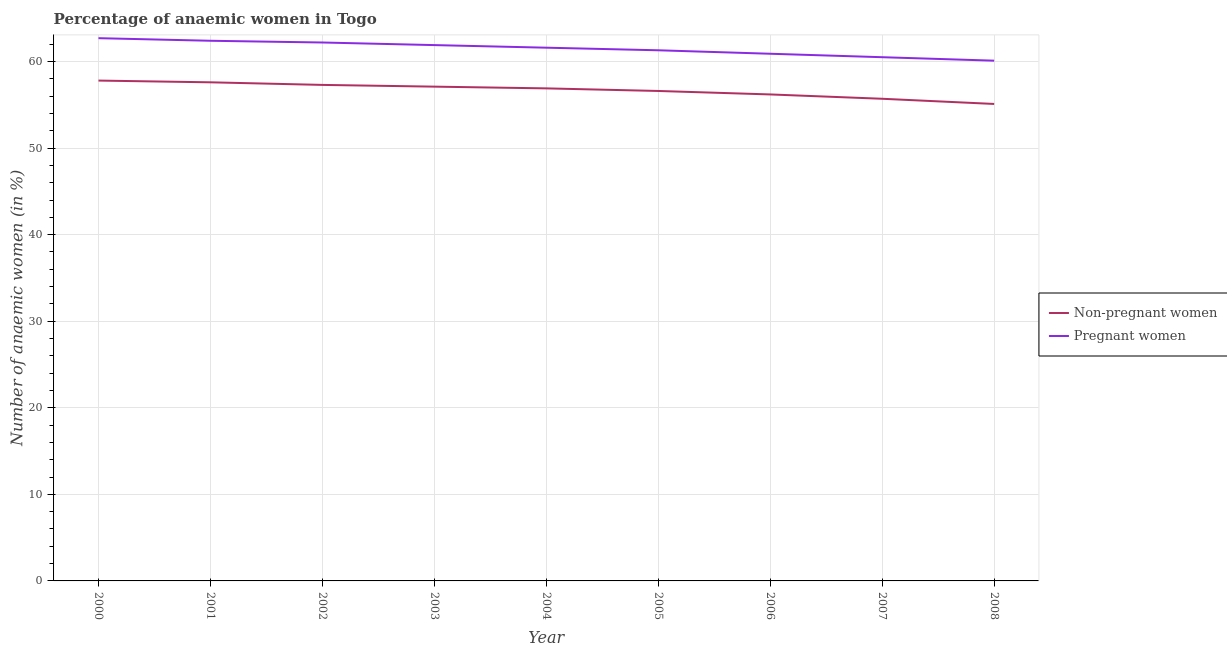Is the number of lines equal to the number of legend labels?
Your answer should be very brief. Yes. What is the percentage of pregnant anaemic women in 2006?
Offer a very short reply. 60.9. Across all years, what is the maximum percentage of non-pregnant anaemic women?
Your answer should be very brief. 57.8. Across all years, what is the minimum percentage of pregnant anaemic women?
Ensure brevity in your answer.  60.1. In which year was the percentage of non-pregnant anaemic women minimum?
Your answer should be very brief. 2008. What is the total percentage of non-pregnant anaemic women in the graph?
Keep it short and to the point. 510.3. What is the difference between the percentage of non-pregnant anaemic women in 2000 and that in 2004?
Give a very brief answer. 0.9. What is the average percentage of non-pregnant anaemic women per year?
Keep it short and to the point. 56.7. In the year 2002, what is the difference between the percentage of non-pregnant anaemic women and percentage of pregnant anaemic women?
Provide a short and direct response. -4.9. In how many years, is the percentage of non-pregnant anaemic women greater than 34 %?
Give a very brief answer. 9. What is the ratio of the percentage of pregnant anaemic women in 2003 to that in 2007?
Offer a very short reply. 1.02. Is the percentage of pregnant anaemic women in 2004 less than that in 2007?
Ensure brevity in your answer.  No. Is the difference between the percentage of pregnant anaemic women in 2002 and 2004 greater than the difference between the percentage of non-pregnant anaemic women in 2002 and 2004?
Your response must be concise. Yes. What is the difference between the highest and the second highest percentage of pregnant anaemic women?
Give a very brief answer. 0.3. What is the difference between the highest and the lowest percentage of non-pregnant anaemic women?
Provide a short and direct response. 2.7. Is the sum of the percentage of non-pregnant anaemic women in 2004 and 2008 greater than the maximum percentage of pregnant anaemic women across all years?
Your answer should be compact. Yes. Does the percentage of pregnant anaemic women monotonically increase over the years?
Provide a short and direct response. No. Are the values on the major ticks of Y-axis written in scientific E-notation?
Provide a short and direct response. No. Does the graph contain grids?
Provide a succinct answer. Yes. How are the legend labels stacked?
Provide a succinct answer. Vertical. What is the title of the graph?
Provide a succinct answer. Percentage of anaemic women in Togo. Does "State government" appear as one of the legend labels in the graph?
Ensure brevity in your answer.  No. What is the label or title of the Y-axis?
Provide a short and direct response. Number of anaemic women (in %). What is the Number of anaemic women (in %) of Non-pregnant women in 2000?
Offer a very short reply. 57.8. What is the Number of anaemic women (in %) in Pregnant women in 2000?
Provide a succinct answer. 62.7. What is the Number of anaemic women (in %) in Non-pregnant women in 2001?
Make the answer very short. 57.6. What is the Number of anaemic women (in %) in Pregnant women in 2001?
Your answer should be very brief. 62.4. What is the Number of anaemic women (in %) in Non-pregnant women in 2002?
Keep it short and to the point. 57.3. What is the Number of anaemic women (in %) in Pregnant women in 2002?
Your answer should be very brief. 62.2. What is the Number of anaemic women (in %) in Non-pregnant women in 2003?
Your answer should be compact. 57.1. What is the Number of anaemic women (in %) in Pregnant women in 2003?
Give a very brief answer. 61.9. What is the Number of anaemic women (in %) in Non-pregnant women in 2004?
Provide a short and direct response. 56.9. What is the Number of anaemic women (in %) in Pregnant women in 2004?
Provide a short and direct response. 61.6. What is the Number of anaemic women (in %) in Non-pregnant women in 2005?
Your answer should be very brief. 56.6. What is the Number of anaemic women (in %) of Pregnant women in 2005?
Make the answer very short. 61.3. What is the Number of anaemic women (in %) in Non-pregnant women in 2006?
Provide a succinct answer. 56.2. What is the Number of anaemic women (in %) in Pregnant women in 2006?
Ensure brevity in your answer.  60.9. What is the Number of anaemic women (in %) of Non-pregnant women in 2007?
Provide a succinct answer. 55.7. What is the Number of anaemic women (in %) in Pregnant women in 2007?
Keep it short and to the point. 60.5. What is the Number of anaemic women (in %) of Non-pregnant women in 2008?
Make the answer very short. 55.1. What is the Number of anaemic women (in %) in Pregnant women in 2008?
Your response must be concise. 60.1. Across all years, what is the maximum Number of anaemic women (in %) of Non-pregnant women?
Offer a very short reply. 57.8. Across all years, what is the maximum Number of anaemic women (in %) in Pregnant women?
Your answer should be compact. 62.7. Across all years, what is the minimum Number of anaemic women (in %) in Non-pregnant women?
Offer a terse response. 55.1. Across all years, what is the minimum Number of anaemic women (in %) in Pregnant women?
Give a very brief answer. 60.1. What is the total Number of anaemic women (in %) in Non-pregnant women in the graph?
Your response must be concise. 510.3. What is the total Number of anaemic women (in %) of Pregnant women in the graph?
Your response must be concise. 553.6. What is the difference between the Number of anaemic women (in %) of Pregnant women in 2000 and that in 2001?
Offer a very short reply. 0.3. What is the difference between the Number of anaemic women (in %) of Non-pregnant women in 2000 and that in 2002?
Offer a very short reply. 0.5. What is the difference between the Number of anaemic women (in %) in Pregnant women in 2000 and that in 2002?
Make the answer very short. 0.5. What is the difference between the Number of anaemic women (in %) in Non-pregnant women in 2000 and that in 2004?
Keep it short and to the point. 0.9. What is the difference between the Number of anaemic women (in %) of Pregnant women in 2000 and that in 2005?
Your answer should be very brief. 1.4. What is the difference between the Number of anaemic women (in %) in Non-pregnant women in 2000 and that in 2006?
Keep it short and to the point. 1.6. What is the difference between the Number of anaemic women (in %) of Pregnant women in 2000 and that in 2006?
Provide a short and direct response. 1.8. What is the difference between the Number of anaemic women (in %) in Non-pregnant women in 2000 and that in 2007?
Your answer should be very brief. 2.1. What is the difference between the Number of anaemic women (in %) of Pregnant women in 2000 and that in 2007?
Your answer should be compact. 2.2. What is the difference between the Number of anaemic women (in %) in Pregnant women in 2000 and that in 2008?
Your response must be concise. 2.6. What is the difference between the Number of anaemic women (in %) in Non-pregnant women in 2001 and that in 2002?
Offer a terse response. 0.3. What is the difference between the Number of anaemic women (in %) in Pregnant women in 2001 and that in 2002?
Your answer should be compact. 0.2. What is the difference between the Number of anaemic women (in %) of Pregnant women in 2001 and that in 2003?
Your answer should be very brief. 0.5. What is the difference between the Number of anaemic women (in %) of Pregnant women in 2001 and that in 2006?
Offer a very short reply. 1.5. What is the difference between the Number of anaemic women (in %) in Non-pregnant women in 2002 and that in 2003?
Give a very brief answer. 0.2. What is the difference between the Number of anaemic women (in %) of Non-pregnant women in 2002 and that in 2004?
Your answer should be compact. 0.4. What is the difference between the Number of anaemic women (in %) of Pregnant women in 2002 and that in 2004?
Your answer should be compact. 0.6. What is the difference between the Number of anaemic women (in %) of Non-pregnant women in 2002 and that in 2005?
Make the answer very short. 0.7. What is the difference between the Number of anaemic women (in %) of Non-pregnant women in 2002 and that in 2006?
Provide a short and direct response. 1.1. What is the difference between the Number of anaemic women (in %) of Pregnant women in 2002 and that in 2006?
Offer a very short reply. 1.3. What is the difference between the Number of anaemic women (in %) of Pregnant women in 2002 and that in 2007?
Give a very brief answer. 1.7. What is the difference between the Number of anaemic women (in %) of Non-pregnant women in 2003 and that in 2005?
Your answer should be very brief. 0.5. What is the difference between the Number of anaemic women (in %) of Non-pregnant women in 2003 and that in 2006?
Make the answer very short. 0.9. What is the difference between the Number of anaemic women (in %) of Non-pregnant women in 2003 and that in 2007?
Your answer should be very brief. 1.4. What is the difference between the Number of anaemic women (in %) in Pregnant women in 2003 and that in 2007?
Your response must be concise. 1.4. What is the difference between the Number of anaemic women (in %) of Non-pregnant women in 2003 and that in 2008?
Ensure brevity in your answer.  2. What is the difference between the Number of anaemic women (in %) in Pregnant women in 2003 and that in 2008?
Keep it short and to the point. 1.8. What is the difference between the Number of anaemic women (in %) in Non-pregnant women in 2004 and that in 2005?
Your answer should be compact. 0.3. What is the difference between the Number of anaemic women (in %) in Non-pregnant women in 2004 and that in 2006?
Your answer should be compact. 0.7. What is the difference between the Number of anaemic women (in %) of Pregnant women in 2004 and that in 2006?
Give a very brief answer. 0.7. What is the difference between the Number of anaemic women (in %) in Non-pregnant women in 2004 and that in 2007?
Your answer should be compact. 1.2. What is the difference between the Number of anaemic women (in %) in Pregnant women in 2004 and that in 2007?
Make the answer very short. 1.1. What is the difference between the Number of anaemic women (in %) in Non-pregnant women in 2004 and that in 2008?
Offer a very short reply. 1.8. What is the difference between the Number of anaemic women (in %) of Non-pregnant women in 2005 and that in 2006?
Offer a very short reply. 0.4. What is the difference between the Number of anaemic women (in %) in Pregnant women in 2005 and that in 2006?
Ensure brevity in your answer.  0.4. What is the difference between the Number of anaemic women (in %) in Non-pregnant women in 2005 and that in 2007?
Provide a short and direct response. 0.9. What is the difference between the Number of anaemic women (in %) in Pregnant women in 2005 and that in 2007?
Offer a terse response. 0.8. What is the difference between the Number of anaemic women (in %) of Non-pregnant women in 2005 and that in 2008?
Your answer should be compact. 1.5. What is the difference between the Number of anaemic women (in %) of Pregnant women in 2005 and that in 2008?
Provide a short and direct response. 1.2. What is the difference between the Number of anaemic women (in %) of Non-pregnant women in 2006 and that in 2007?
Keep it short and to the point. 0.5. What is the difference between the Number of anaemic women (in %) of Non-pregnant women in 2007 and that in 2008?
Ensure brevity in your answer.  0.6. What is the difference between the Number of anaemic women (in %) of Non-pregnant women in 2000 and the Number of anaemic women (in %) of Pregnant women in 2001?
Your answer should be very brief. -4.6. What is the difference between the Number of anaemic women (in %) of Non-pregnant women in 2000 and the Number of anaemic women (in %) of Pregnant women in 2002?
Provide a succinct answer. -4.4. What is the difference between the Number of anaemic women (in %) of Non-pregnant women in 2000 and the Number of anaemic women (in %) of Pregnant women in 2004?
Provide a short and direct response. -3.8. What is the difference between the Number of anaemic women (in %) of Non-pregnant women in 2000 and the Number of anaemic women (in %) of Pregnant women in 2007?
Offer a terse response. -2.7. What is the difference between the Number of anaemic women (in %) in Non-pregnant women in 2001 and the Number of anaemic women (in %) in Pregnant women in 2002?
Make the answer very short. -4.6. What is the difference between the Number of anaemic women (in %) of Non-pregnant women in 2001 and the Number of anaemic women (in %) of Pregnant women in 2004?
Provide a succinct answer. -4. What is the difference between the Number of anaemic women (in %) in Non-pregnant women in 2001 and the Number of anaemic women (in %) in Pregnant women in 2005?
Provide a succinct answer. -3.7. What is the difference between the Number of anaemic women (in %) of Non-pregnant women in 2001 and the Number of anaemic women (in %) of Pregnant women in 2006?
Provide a succinct answer. -3.3. What is the difference between the Number of anaemic women (in %) in Non-pregnant women in 2002 and the Number of anaemic women (in %) in Pregnant women in 2005?
Your response must be concise. -4. What is the difference between the Number of anaemic women (in %) of Non-pregnant women in 2002 and the Number of anaemic women (in %) of Pregnant women in 2008?
Give a very brief answer. -2.8. What is the difference between the Number of anaemic women (in %) of Non-pregnant women in 2003 and the Number of anaemic women (in %) of Pregnant women in 2005?
Provide a succinct answer. -4.2. What is the difference between the Number of anaemic women (in %) of Non-pregnant women in 2003 and the Number of anaemic women (in %) of Pregnant women in 2007?
Offer a very short reply. -3.4. What is the difference between the Number of anaemic women (in %) in Non-pregnant women in 2003 and the Number of anaemic women (in %) in Pregnant women in 2008?
Provide a succinct answer. -3. What is the difference between the Number of anaemic women (in %) of Non-pregnant women in 2004 and the Number of anaemic women (in %) of Pregnant women in 2007?
Offer a terse response. -3.6. What is the difference between the Number of anaemic women (in %) in Non-pregnant women in 2005 and the Number of anaemic women (in %) in Pregnant women in 2006?
Provide a short and direct response. -4.3. What is the difference between the Number of anaemic women (in %) in Non-pregnant women in 2005 and the Number of anaemic women (in %) in Pregnant women in 2007?
Provide a succinct answer. -3.9. What is the difference between the Number of anaemic women (in %) of Non-pregnant women in 2006 and the Number of anaemic women (in %) of Pregnant women in 2007?
Your response must be concise. -4.3. What is the average Number of anaemic women (in %) of Non-pregnant women per year?
Ensure brevity in your answer.  56.7. What is the average Number of anaemic women (in %) of Pregnant women per year?
Provide a succinct answer. 61.51. In the year 2001, what is the difference between the Number of anaemic women (in %) in Non-pregnant women and Number of anaemic women (in %) in Pregnant women?
Provide a short and direct response. -4.8. In the year 2002, what is the difference between the Number of anaemic women (in %) of Non-pregnant women and Number of anaemic women (in %) of Pregnant women?
Your answer should be compact. -4.9. In the year 2003, what is the difference between the Number of anaemic women (in %) in Non-pregnant women and Number of anaemic women (in %) in Pregnant women?
Ensure brevity in your answer.  -4.8. In the year 2006, what is the difference between the Number of anaemic women (in %) of Non-pregnant women and Number of anaemic women (in %) of Pregnant women?
Offer a very short reply. -4.7. In the year 2007, what is the difference between the Number of anaemic women (in %) in Non-pregnant women and Number of anaemic women (in %) in Pregnant women?
Give a very brief answer. -4.8. What is the ratio of the Number of anaemic women (in %) of Non-pregnant women in 2000 to that in 2001?
Offer a terse response. 1. What is the ratio of the Number of anaemic women (in %) in Non-pregnant women in 2000 to that in 2002?
Make the answer very short. 1.01. What is the ratio of the Number of anaemic women (in %) of Pregnant women in 2000 to that in 2002?
Offer a very short reply. 1.01. What is the ratio of the Number of anaemic women (in %) of Non-pregnant women in 2000 to that in 2003?
Give a very brief answer. 1.01. What is the ratio of the Number of anaemic women (in %) of Pregnant women in 2000 to that in 2003?
Make the answer very short. 1.01. What is the ratio of the Number of anaemic women (in %) of Non-pregnant women in 2000 to that in 2004?
Your response must be concise. 1.02. What is the ratio of the Number of anaemic women (in %) in Pregnant women in 2000 to that in 2004?
Keep it short and to the point. 1.02. What is the ratio of the Number of anaemic women (in %) in Non-pregnant women in 2000 to that in 2005?
Keep it short and to the point. 1.02. What is the ratio of the Number of anaemic women (in %) in Pregnant women in 2000 to that in 2005?
Provide a succinct answer. 1.02. What is the ratio of the Number of anaemic women (in %) in Non-pregnant women in 2000 to that in 2006?
Provide a short and direct response. 1.03. What is the ratio of the Number of anaemic women (in %) of Pregnant women in 2000 to that in 2006?
Give a very brief answer. 1.03. What is the ratio of the Number of anaemic women (in %) in Non-pregnant women in 2000 to that in 2007?
Ensure brevity in your answer.  1.04. What is the ratio of the Number of anaemic women (in %) of Pregnant women in 2000 to that in 2007?
Make the answer very short. 1.04. What is the ratio of the Number of anaemic women (in %) in Non-pregnant women in 2000 to that in 2008?
Your response must be concise. 1.05. What is the ratio of the Number of anaemic women (in %) of Pregnant women in 2000 to that in 2008?
Offer a very short reply. 1.04. What is the ratio of the Number of anaemic women (in %) of Pregnant women in 2001 to that in 2002?
Provide a short and direct response. 1. What is the ratio of the Number of anaemic women (in %) of Non-pregnant women in 2001 to that in 2003?
Provide a short and direct response. 1.01. What is the ratio of the Number of anaemic women (in %) in Pregnant women in 2001 to that in 2003?
Give a very brief answer. 1.01. What is the ratio of the Number of anaemic women (in %) in Non-pregnant women in 2001 to that in 2004?
Keep it short and to the point. 1.01. What is the ratio of the Number of anaemic women (in %) in Non-pregnant women in 2001 to that in 2005?
Provide a short and direct response. 1.02. What is the ratio of the Number of anaemic women (in %) in Pregnant women in 2001 to that in 2005?
Keep it short and to the point. 1.02. What is the ratio of the Number of anaemic women (in %) of Non-pregnant women in 2001 to that in 2006?
Ensure brevity in your answer.  1.02. What is the ratio of the Number of anaemic women (in %) in Pregnant women in 2001 to that in 2006?
Offer a terse response. 1.02. What is the ratio of the Number of anaemic women (in %) of Non-pregnant women in 2001 to that in 2007?
Your response must be concise. 1.03. What is the ratio of the Number of anaemic women (in %) of Pregnant women in 2001 to that in 2007?
Provide a short and direct response. 1.03. What is the ratio of the Number of anaemic women (in %) of Non-pregnant women in 2001 to that in 2008?
Give a very brief answer. 1.05. What is the ratio of the Number of anaemic women (in %) in Pregnant women in 2001 to that in 2008?
Offer a very short reply. 1.04. What is the ratio of the Number of anaemic women (in %) of Pregnant women in 2002 to that in 2004?
Offer a very short reply. 1.01. What is the ratio of the Number of anaemic women (in %) of Non-pregnant women in 2002 to that in 2005?
Provide a short and direct response. 1.01. What is the ratio of the Number of anaemic women (in %) in Pregnant women in 2002 to that in 2005?
Give a very brief answer. 1.01. What is the ratio of the Number of anaemic women (in %) of Non-pregnant women in 2002 to that in 2006?
Your answer should be very brief. 1.02. What is the ratio of the Number of anaemic women (in %) of Pregnant women in 2002 to that in 2006?
Your response must be concise. 1.02. What is the ratio of the Number of anaemic women (in %) of Non-pregnant women in 2002 to that in 2007?
Give a very brief answer. 1.03. What is the ratio of the Number of anaemic women (in %) of Pregnant women in 2002 to that in 2007?
Keep it short and to the point. 1.03. What is the ratio of the Number of anaemic women (in %) of Non-pregnant women in 2002 to that in 2008?
Your answer should be very brief. 1.04. What is the ratio of the Number of anaemic women (in %) of Pregnant women in 2002 to that in 2008?
Your answer should be very brief. 1.03. What is the ratio of the Number of anaemic women (in %) in Non-pregnant women in 2003 to that in 2004?
Offer a very short reply. 1. What is the ratio of the Number of anaemic women (in %) of Pregnant women in 2003 to that in 2004?
Your answer should be very brief. 1. What is the ratio of the Number of anaemic women (in %) in Non-pregnant women in 2003 to that in 2005?
Make the answer very short. 1.01. What is the ratio of the Number of anaemic women (in %) of Pregnant women in 2003 to that in 2005?
Your answer should be compact. 1.01. What is the ratio of the Number of anaemic women (in %) in Non-pregnant women in 2003 to that in 2006?
Your answer should be very brief. 1.02. What is the ratio of the Number of anaemic women (in %) of Pregnant women in 2003 to that in 2006?
Make the answer very short. 1.02. What is the ratio of the Number of anaemic women (in %) of Non-pregnant women in 2003 to that in 2007?
Make the answer very short. 1.03. What is the ratio of the Number of anaemic women (in %) in Pregnant women in 2003 to that in 2007?
Make the answer very short. 1.02. What is the ratio of the Number of anaemic women (in %) in Non-pregnant women in 2003 to that in 2008?
Keep it short and to the point. 1.04. What is the ratio of the Number of anaemic women (in %) in Non-pregnant women in 2004 to that in 2005?
Make the answer very short. 1.01. What is the ratio of the Number of anaemic women (in %) in Pregnant women in 2004 to that in 2005?
Give a very brief answer. 1. What is the ratio of the Number of anaemic women (in %) of Non-pregnant women in 2004 to that in 2006?
Your answer should be compact. 1.01. What is the ratio of the Number of anaemic women (in %) in Pregnant women in 2004 to that in 2006?
Your answer should be compact. 1.01. What is the ratio of the Number of anaemic women (in %) in Non-pregnant women in 2004 to that in 2007?
Provide a short and direct response. 1.02. What is the ratio of the Number of anaemic women (in %) of Pregnant women in 2004 to that in 2007?
Provide a succinct answer. 1.02. What is the ratio of the Number of anaemic women (in %) of Non-pregnant women in 2004 to that in 2008?
Your response must be concise. 1.03. What is the ratio of the Number of anaemic women (in %) of Pregnant women in 2004 to that in 2008?
Provide a short and direct response. 1.02. What is the ratio of the Number of anaemic women (in %) of Non-pregnant women in 2005 to that in 2006?
Your answer should be compact. 1.01. What is the ratio of the Number of anaemic women (in %) in Pregnant women in 2005 to that in 2006?
Give a very brief answer. 1.01. What is the ratio of the Number of anaemic women (in %) in Non-pregnant women in 2005 to that in 2007?
Provide a short and direct response. 1.02. What is the ratio of the Number of anaemic women (in %) of Pregnant women in 2005 to that in 2007?
Keep it short and to the point. 1.01. What is the ratio of the Number of anaemic women (in %) of Non-pregnant women in 2005 to that in 2008?
Make the answer very short. 1.03. What is the ratio of the Number of anaemic women (in %) of Pregnant women in 2006 to that in 2007?
Provide a short and direct response. 1.01. What is the ratio of the Number of anaemic women (in %) of Pregnant women in 2006 to that in 2008?
Provide a succinct answer. 1.01. What is the ratio of the Number of anaemic women (in %) of Non-pregnant women in 2007 to that in 2008?
Your answer should be compact. 1.01. What is the ratio of the Number of anaemic women (in %) of Pregnant women in 2007 to that in 2008?
Your answer should be very brief. 1.01. What is the difference between the highest and the second highest Number of anaemic women (in %) of Pregnant women?
Offer a very short reply. 0.3. What is the difference between the highest and the lowest Number of anaemic women (in %) of Non-pregnant women?
Offer a very short reply. 2.7. What is the difference between the highest and the lowest Number of anaemic women (in %) of Pregnant women?
Your answer should be very brief. 2.6. 